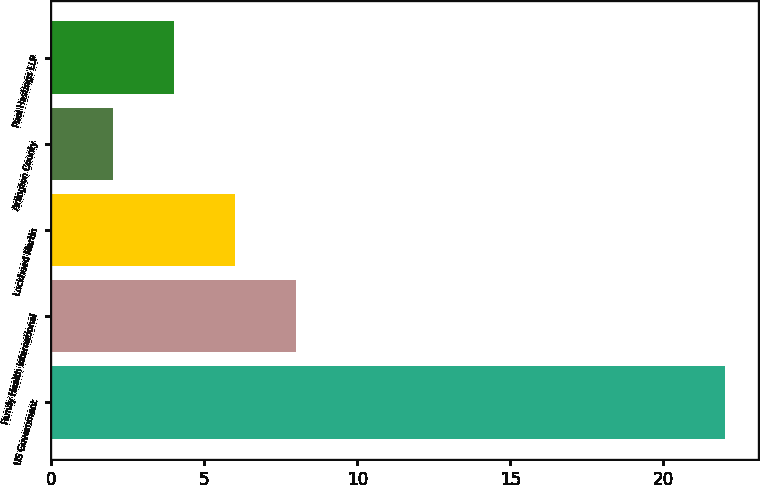Convert chart to OTSL. <chart><loc_0><loc_0><loc_500><loc_500><bar_chart><fcel>US Government<fcel>Family Health International<fcel>Lockheed Martin<fcel>Arlington County<fcel>Paul Hastings LLP<nl><fcel>22<fcel>8<fcel>6<fcel>2<fcel>4<nl></chart> 